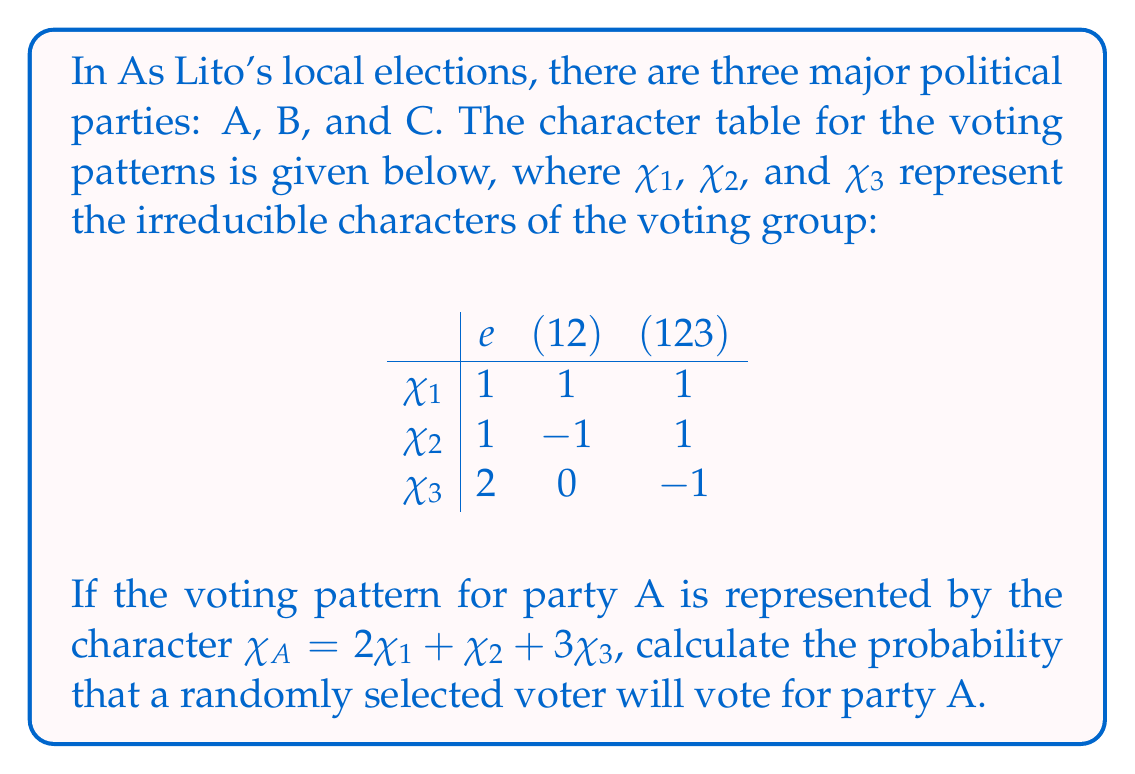Solve this math problem. To solve this problem, we'll follow these steps:

1) First, we need to understand what the character $\chi_A$ represents. In this context, it describes the voting pattern for party A.

2) The dimension of the representation is given by $\chi_A(e)$, where $e$ is the identity element. Let's calculate this:

   $\chi_A(e) = 2\chi_1(e) + \chi_2(e) + 3\chi_3(e)$
   $= 2(1) + 1(1) + 3(2) = 2 + 1 + 6 = 9$

3) This means that the total number of possible voting outcomes is 9.

4) Now, we need to calculate how many of these outcomes favor party A. This is given by the inner product of $\chi_A$ with the trivial character $\chi_1$:

   $\langle \chi_A, \chi_1 \rangle = \frac{1}{|G|} \sum_{g \in G} \chi_A(g) \overline{\chi_1(g)}$

   Where $|G|$ is the order of the group, which is 3 in this case (as there are 3 conjugacy classes).

5) Let's calculate this inner product:

   $\langle \chi_A, \chi_1 \rangle = \frac{1}{3} [(2+1+6)(1) + (2-1+0)(1) + (2+1-3)(1)]$
   $= \frac{1}{3} [9 + 1 + 0] = \frac{10}{3}$

6) This means that out of the 9 possible outcomes, $\frac{10}{3}$ favor party A.

7) Therefore, the probability of a randomly selected voter voting for party A is:

   $P(A) = \frac{10/3}{9} = \frac{10}{27}$
Answer: $\frac{10}{27}$ 